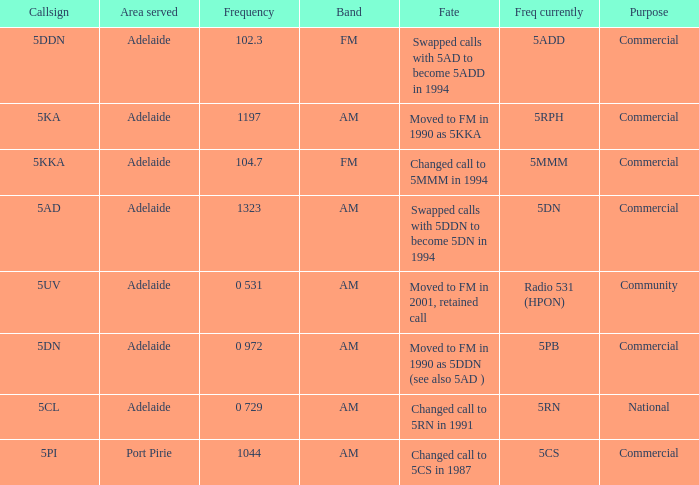Which area served has a Callsign of 5ddn? Adelaide. 